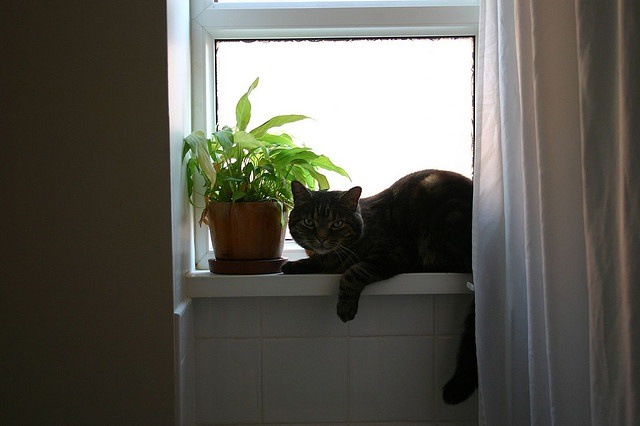Describe the objects in this image and their specific colors. I can see cat in black, gray, and maroon tones and potted plant in black, white, and darkgreen tones in this image. 